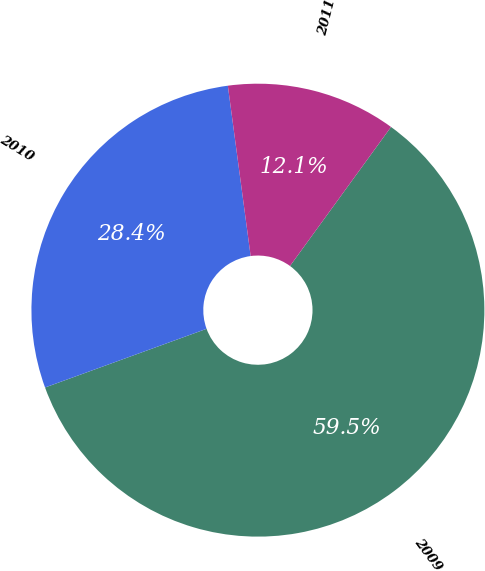Convert chart. <chart><loc_0><loc_0><loc_500><loc_500><pie_chart><fcel>2009<fcel>2010<fcel>2011<nl><fcel>59.46%<fcel>28.43%<fcel>12.12%<nl></chart> 